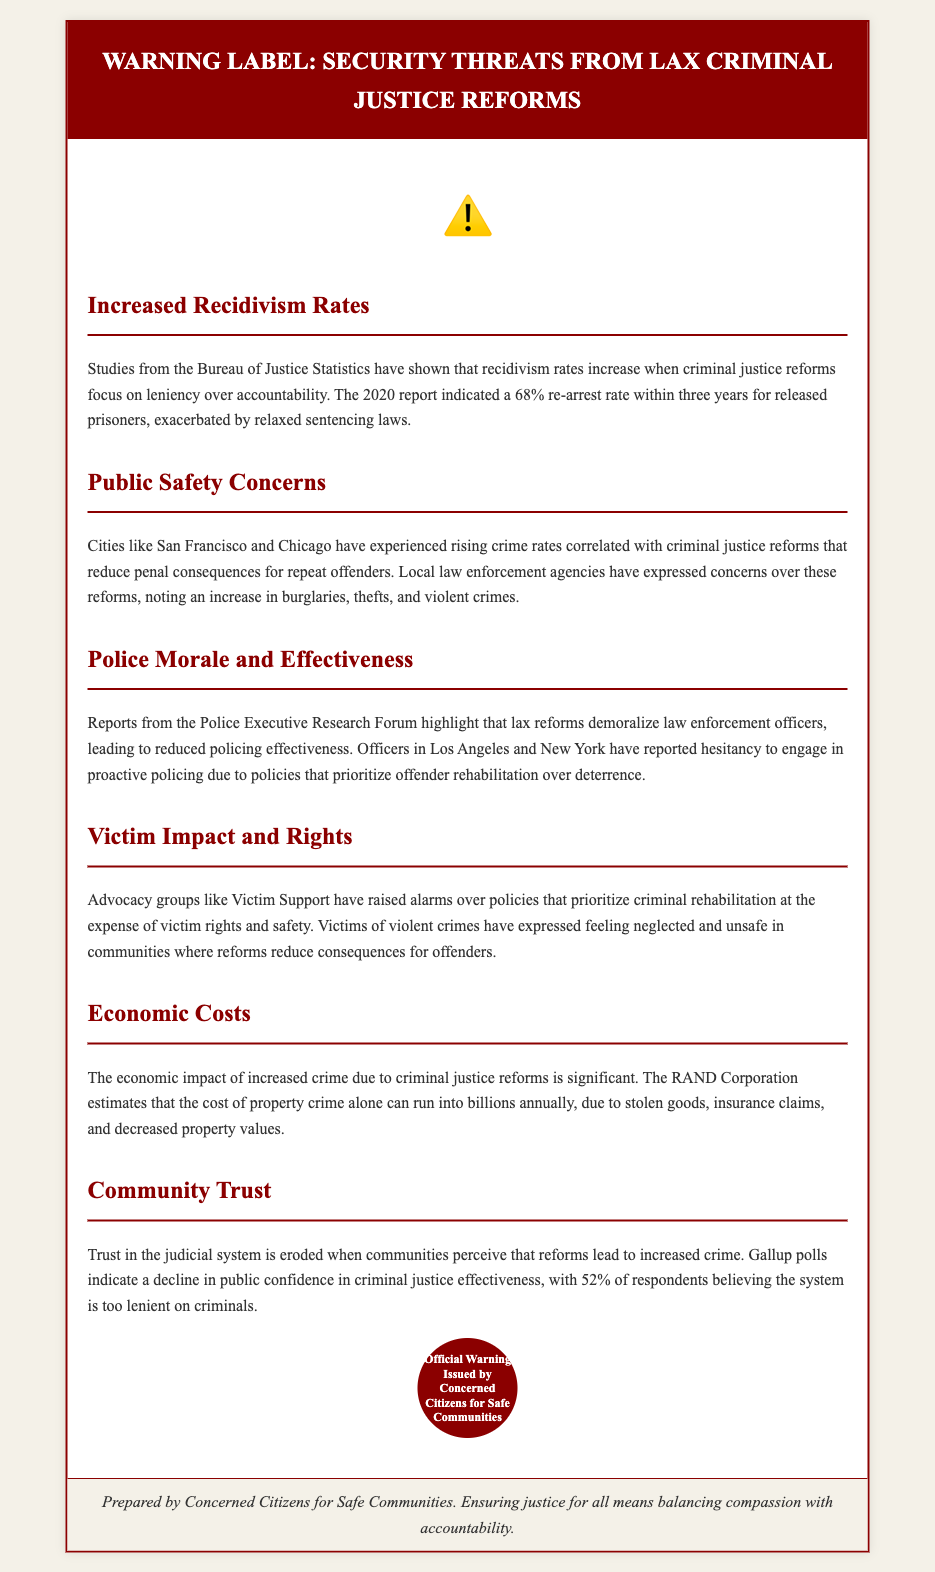What is the recidivism rate mentioned? The document states that the re-arrest rate is 68% within three years for released prisoners.
Answer: 68% Which cities are noted for rising crime rates? The document specifically mentions San Francisco and Chicago in relation to rising crime rates and criminal justice reforms.
Answer: San Francisco and Chicago What organization issued the warning? The warning label is issued by Concerned Citizens for Safe Communities.
Answer: Concerned Citizens for Safe Communities What do advocacy groups say about criminal rehabilitation? Advocacy groups like Victim Support raised alarms over policies prioritizing rehabilitation at the expense of victim rights.
Answer: Victim rights What is the economic impact of increased crime estimated by? The RAND Corporation estimates the cost of property crime can run into billions annually.
Answer: RAND Corporation How many respondents believe the system is too lenient on criminals? According to Gallup polls, 52% of respondents believe the system is too lenient.
Answer: 52% What is the impact of lax reforms on police morale? The document highlights that lax reforms demoralize law enforcement officers.
Answer: Demoralize officers Which type of crimes are specifically mentioned as rising? The document mentions an increase in burglaries, thefts, and violent crimes.
Answer: Burglaries, thefts, and violent crimes 